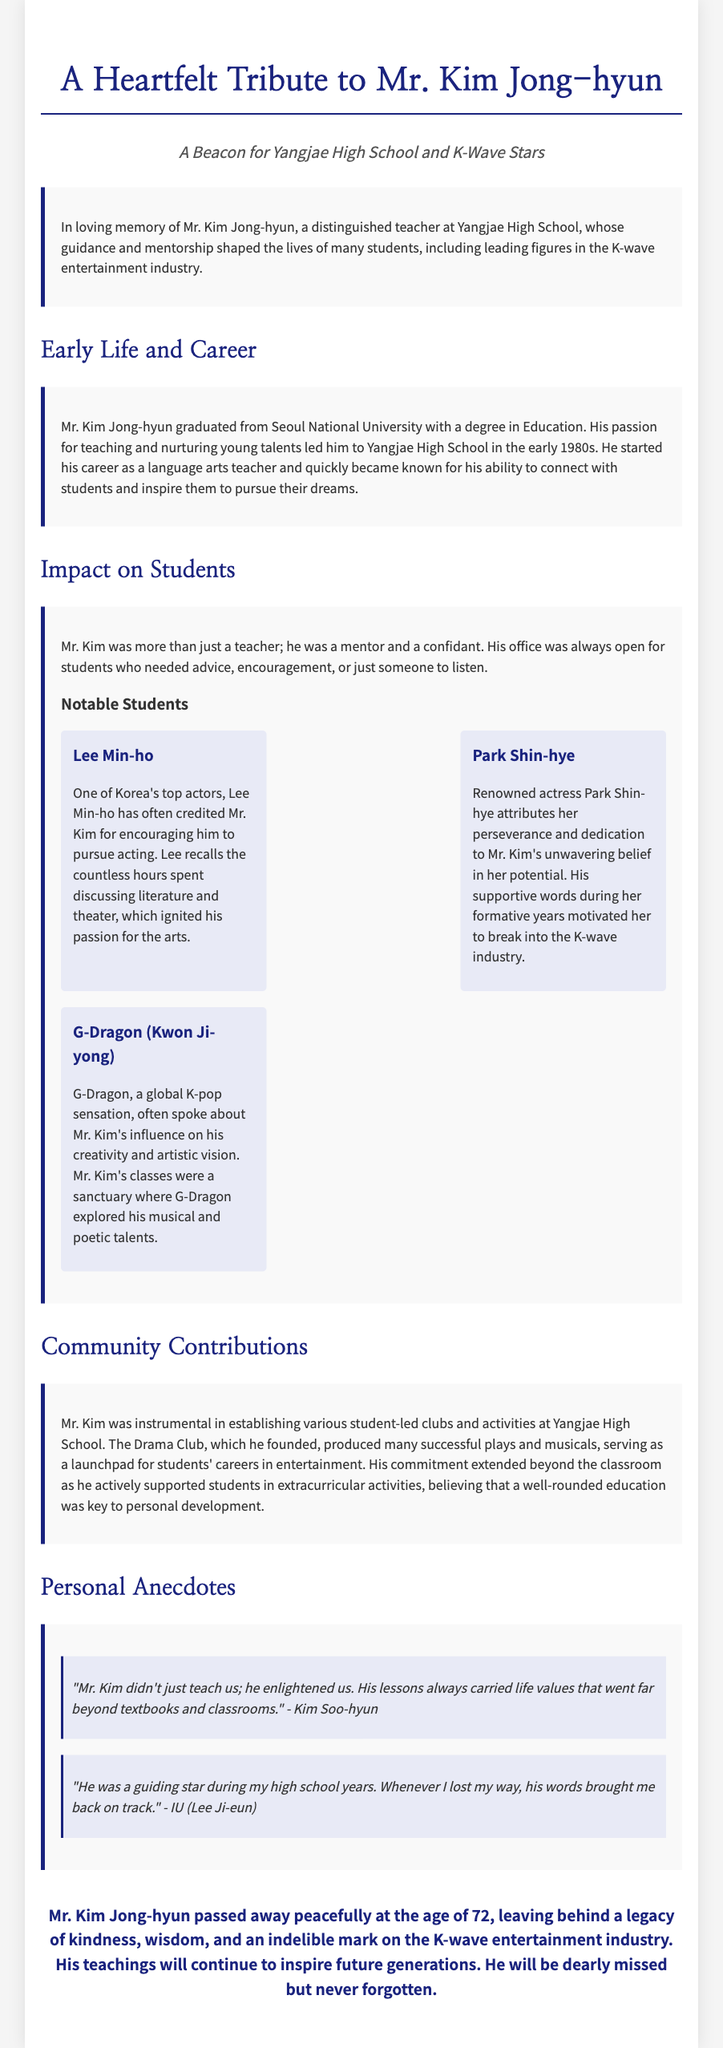What was Mr. Kim Jong-hyun's age at passing? Mr. Kim Jong-hyun passed away at the age of 72, as mentioned in the closing section.
Answer: 72 Which university did Mr. Kim graduate from? The document states that Mr. Kim graduated from Seoul National University.
Answer: Seoul National University What subject did Mr. Kim teach? The document indicates that Mr. Kim started his career as a language arts teacher.
Answer: Language arts Who is one of the notable students mentioned? The document features notable students such as Lee Min-ho, Park Shin-hye, and G-Dragon.
Answer: Lee Min-ho What was the name of the club founded by Mr. Kim? The document mentions that Mr. Kim founded the Drama Club at Yangjae High School.
Answer: Drama Club What does Kim Soo-hyun say about Mr. Kim's teaching? Kim Soo-hyun's quote indicates that Mr. Kim enlightened students and provided life values.
Answer: Enlightened us What kind of support did Mr. Kim offer to students? The document explains that Mr. Kim provided advice and encouragement to students who needed someone to listen.
Answer: Advice and encouragement Which activity did Mr. Kim believe was key to personal development? The document states that Mr. Kim believed a well-rounded education was key to personal development.
Answer: Well-rounded education How did G-Dragon refer to Mr. Kim's class? G-Dragon described Mr. Kim's classes as a sanctuary for exploring his talents.
Answer: Sanctuary 